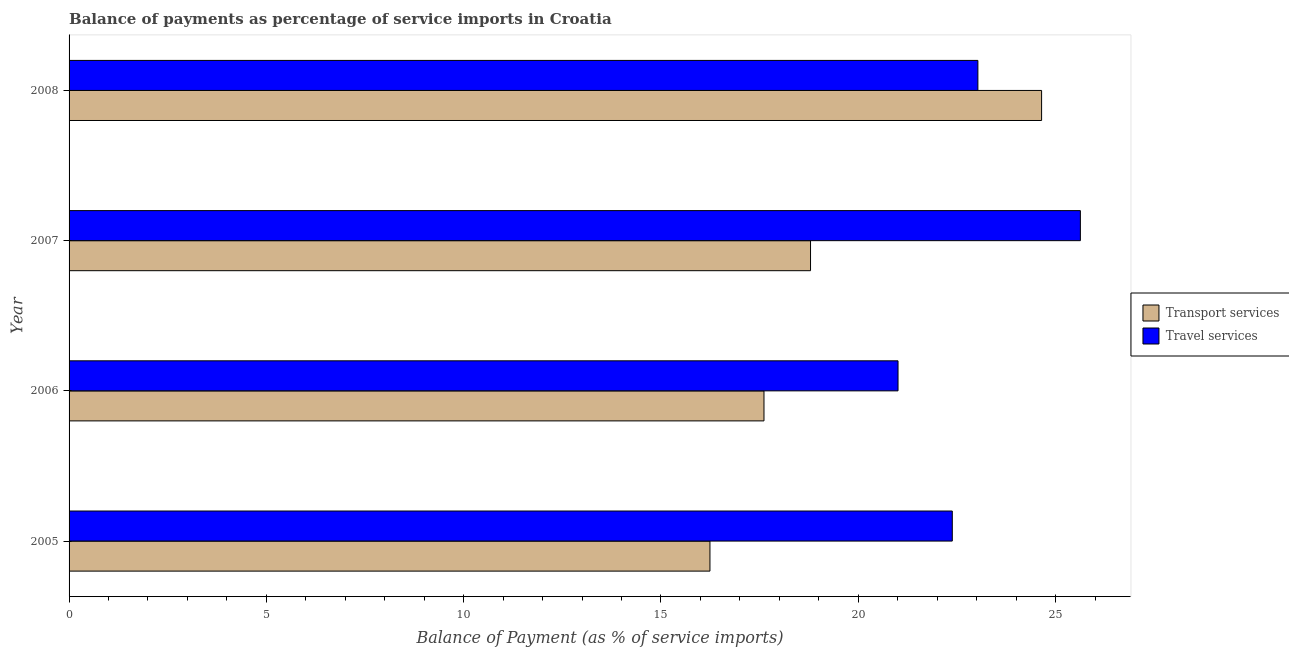How many different coloured bars are there?
Give a very brief answer. 2. Are the number of bars per tick equal to the number of legend labels?
Your answer should be compact. Yes. What is the label of the 4th group of bars from the top?
Make the answer very short. 2005. What is the balance of payments of travel services in 2007?
Offer a terse response. 25.63. Across all years, what is the maximum balance of payments of travel services?
Keep it short and to the point. 25.63. Across all years, what is the minimum balance of payments of transport services?
Give a very brief answer. 16.24. What is the total balance of payments of transport services in the graph?
Make the answer very short. 77.29. What is the difference between the balance of payments of travel services in 2005 and that in 2007?
Offer a very short reply. -3.25. What is the difference between the balance of payments of travel services in 2008 and the balance of payments of transport services in 2007?
Your answer should be very brief. 4.24. What is the average balance of payments of travel services per year?
Keep it short and to the point. 23.01. In the year 2005, what is the difference between the balance of payments of travel services and balance of payments of transport services?
Keep it short and to the point. 6.14. In how many years, is the balance of payments of travel services greater than 18 %?
Your response must be concise. 4. What is the ratio of the balance of payments of travel services in 2006 to that in 2007?
Keep it short and to the point. 0.82. Is the balance of payments of travel services in 2007 less than that in 2008?
Your response must be concise. No. Is the difference between the balance of payments of transport services in 2006 and 2008 greater than the difference between the balance of payments of travel services in 2006 and 2008?
Give a very brief answer. No. What is the difference between the highest and the second highest balance of payments of travel services?
Give a very brief answer. 2.6. What is the difference between the highest and the lowest balance of payments of travel services?
Your answer should be compact. 4.62. In how many years, is the balance of payments of travel services greater than the average balance of payments of travel services taken over all years?
Provide a short and direct response. 2. What does the 1st bar from the top in 2008 represents?
Your response must be concise. Travel services. What does the 1st bar from the bottom in 2006 represents?
Your response must be concise. Transport services. Are all the bars in the graph horizontal?
Your answer should be compact. Yes. How many years are there in the graph?
Give a very brief answer. 4. What is the difference between two consecutive major ticks on the X-axis?
Offer a terse response. 5. Are the values on the major ticks of X-axis written in scientific E-notation?
Make the answer very short. No. How are the legend labels stacked?
Provide a succinct answer. Vertical. What is the title of the graph?
Keep it short and to the point. Balance of payments as percentage of service imports in Croatia. Does "Taxes on profits and capital gains" appear as one of the legend labels in the graph?
Offer a terse response. No. What is the label or title of the X-axis?
Offer a terse response. Balance of Payment (as % of service imports). What is the label or title of the Y-axis?
Offer a terse response. Year. What is the Balance of Payment (as % of service imports) of Transport services in 2005?
Offer a very short reply. 16.24. What is the Balance of Payment (as % of service imports) of Travel services in 2005?
Provide a short and direct response. 22.38. What is the Balance of Payment (as % of service imports) of Transport services in 2006?
Your response must be concise. 17.61. What is the Balance of Payment (as % of service imports) in Travel services in 2006?
Give a very brief answer. 21.01. What is the Balance of Payment (as % of service imports) in Transport services in 2007?
Keep it short and to the point. 18.79. What is the Balance of Payment (as % of service imports) in Travel services in 2007?
Your answer should be very brief. 25.63. What is the Balance of Payment (as % of service imports) of Transport services in 2008?
Your response must be concise. 24.65. What is the Balance of Payment (as % of service imports) of Travel services in 2008?
Offer a very short reply. 23.03. Across all years, what is the maximum Balance of Payment (as % of service imports) of Transport services?
Offer a terse response. 24.65. Across all years, what is the maximum Balance of Payment (as % of service imports) of Travel services?
Give a very brief answer. 25.63. Across all years, what is the minimum Balance of Payment (as % of service imports) in Transport services?
Your answer should be very brief. 16.24. Across all years, what is the minimum Balance of Payment (as % of service imports) in Travel services?
Offer a terse response. 21.01. What is the total Balance of Payment (as % of service imports) of Transport services in the graph?
Provide a short and direct response. 77.29. What is the total Balance of Payment (as % of service imports) in Travel services in the graph?
Offer a very short reply. 92.05. What is the difference between the Balance of Payment (as % of service imports) in Transport services in 2005 and that in 2006?
Offer a very short reply. -1.37. What is the difference between the Balance of Payment (as % of service imports) of Travel services in 2005 and that in 2006?
Ensure brevity in your answer.  1.38. What is the difference between the Balance of Payment (as % of service imports) of Transport services in 2005 and that in 2007?
Give a very brief answer. -2.55. What is the difference between the Balance of Payment (as % of service imports) in Travel services in 2005 and that in 2007?
Keep it short and to the point. -3.25. What is the difference between the Balance of Payment (as % of service imports) of Transport services in 2005 and that in 2008?
Ensure brevity in your answer.  -8.4. What is the difference between the Balance of Payment (as % of service imports) in Travel services in 2005 and that in 2008?
Give a very brief answer. -0.65. What is the difference between the Balance of Payment (as % of service imports) of Transport services in 2006 and that in 2007?
Your answer should be very brief. -1.18. What is the difference between the Balance of Payment (as % of service imports) of Travel services in 2006 and that in 2007?
Provide a succinct answer. -4.62. What is the difference between the Balance of Payment (as % of service imports) of Transport services in 2006 and that in 2008?
Your answer should be compact. -7.04. What is the difference between the Balance of Payment (as % of service imports) in Travel services in 2006 and that in 2008?
Offer a terse response. -2.02. What is the difference between the Balance of Payment (as % of service imports) in Transport services in 2007 and that in 2008?
Offer a very short reply. -5.86. What is the difference between the Balance of Payment (as % of service imports) of Travel services in 2007 and that in 2008?
Your answer should be compact. 2.6. What is the difference between the Balance of Payment (as % of service imports) of Transport services in 2005 and the Balance of Payment (as % of service imports) of Travel services in 2006?
Provide a succinct answer. -4.77. What is the difference between the Balance of Payment (as % of service imports) in Transport services in 2005 and the Balance of Payment (as % of service imports) in Travel services in 2007?
Provide a succinct answer. -9.39. What is the difference between the Balance of Payment (as % of service imports) of Transport services in 2005 and the Balance of Payment (as % of service imports) of Travel services in 2008?
Keep it short and to the point. -6.79. What is the difference between the Balance of Payment (as % of service imports) in Transport services in 2006 and the Balance of Payment (as % of service imports) in Travel services in 2007?
Keep it short and to the point. -8.02. What is the difference between the Balance of Payment (as % of service imports) in Transport services in 2006 and the Balance of Payment (as % of service imports) in Travel services in 2008?
Make the answer very short. -5.42. What is the difference between the Balance of Payment (as % of service imports) in Transport services in 2007 and the Balance of Payment (as % of service imports) in Travel services in 2008?
Provide a succinct answer. -4.24. What is the average Balance of Payment (as % of service imports) of Transport services per year?
Offer a terse response. 19.32. What is the average Balance of Payment (as % of service imports) in Travel services per year?
Make the answer very short. 23.01. In the year 2005, what is the difference between the Balance of Payment (as % of service imports) in Transport services and Balance of Payment (as % of service imports) in Travel services?
Provide a succinct answer. -6.14. In the year 2006, what is the difference between the Balance of Payment (as % of service imports) in Transport services and Balance of Payment (as % of service imports) in Travel services?
Keep it short and to the point. -3.4. In the year 2007, what is the difference between the Balance of Payment (as % of service imports) in Transport services and Balance of Payment (as % of service imports) in Travel services?
Give a very brief answer. -6.84. In the year 2008, what is the difference between the Balance of Payment (as % of service imports) in Transport services and Balance of Payment (as % of service imports) in Travel services?
Your answer should be compact. 1.61. What is the ratio of the Balance of Payment (as % of service imports) of Transport services in 2005 to that in 2006?
Provide a succinct answer. 0.92. What is the ratio of the Balance of Payment (as % of service imports) in Travel services in 2005 to that in 2006?
Your answer should be compact. 1.07. What is the ratio of the Balance of Payment (as % of service imports) in Transport services in 2005 to that in 2007?
Make the answer very short. 0.86. What is the ratio of the Balance of Payment (as % of service imports) in Travel services in 2005 to that in 2007?
Offer a very short reply. 0.87. What is the ratio of the Balance of Payment (as % of service imports) of Transport services in 2005 to that in 2008?
Offer a terse response. 0.66. What is the ratio of the Balance of Payment (as % of service imports) in Travel services in 2005 to that in 2008?
Offer a terse response. 0.97. What is the ratio of the Balance of Payment (as % of service imports) in Transport services in 2006 to that in 2007?
Provide a short and direct response. 0.94. What is the ratio of the Balance of Payment (as % of service imports) of Travel services in 2006 to that in 2007?
Offer a very short reply. 0.82. What is the ratio of the Balance of Payment (as % of service imports) in Transport services in 2006 to that in 2008?
Provide a succinct answer. 0.71. What is the ratio of the Balance of Payment (as % of service imports) of Travel services in 2006 to that in 2008?
Your answer should be very brief. 0.91. What is the ratio of the Balance of Payment (as % of service imports) in Transport services in 2007 to that in 2008?
Make the answer very short. 0.76. What is the ratio of the Balance of Payment (as % of service imports) of Travel services in 2007 to that in 2008?
Provide a short and direct response. 1.11. What is the difference between the highest and the second highest Balance of Payment (as % of service imports) of Transport services?
Ensure brevity in your answer.  5.86. What is the difference between the highest and the second highest Balance of Payment (as % of service imports) in Travel services?
Your answer should be compact. 2.6. What is the difference between the highest and the lowest Balance of Payment (as % of service imports) of Transport services?
Ensure brevity in your answer.  8.4. What is the difference between the highest and the lowest Balance of Payment (as % of service imports) of Travel services?
Your answer should be compact. 4.62. 